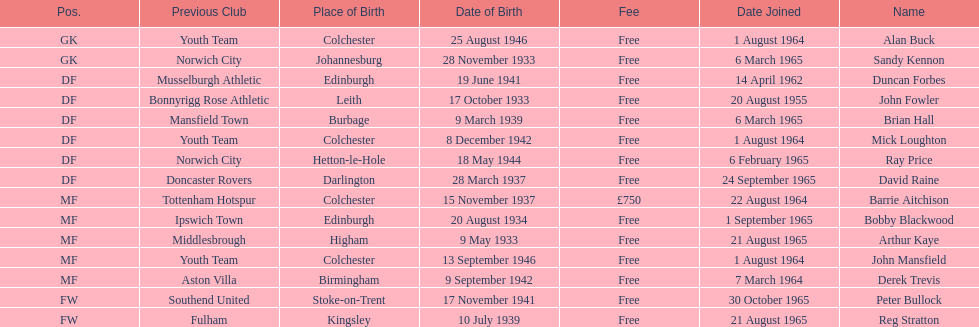What is the date of the lst player that joined? 20 August 1955. 